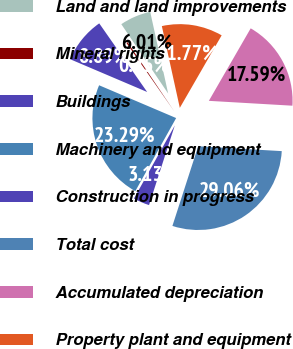Convert chart to OTSL. <chart><loc_0><loc_0><loc_500><loc_500><pie_chart><fcel>Land and land improvements<fcel>Mineral rights<fcel>Buildings<fcel>Machinery and equipment<fcel>Construction in progress<fcel>Total cost<fcel>Accumulated depreciation<fcel>Property plant and equipment<nl><fcel>6.01%<fcel>0.25%<fcel>8.89%<fcel>23.29%<fcel>3.13%<fcel>29.05%<fcel>17.59%<fcel>11.77%<nl></chart> 